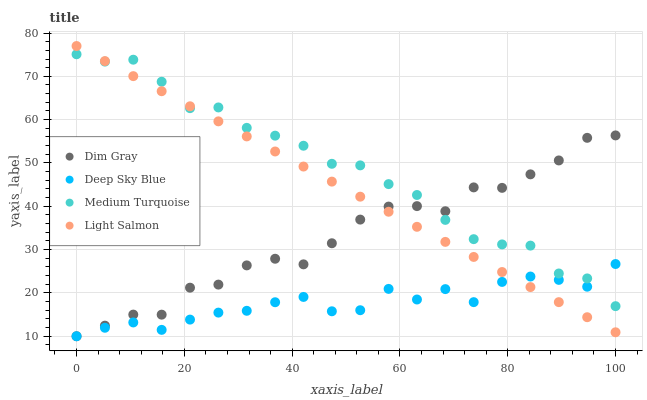Does Deep Sky Blue have the minimum area under the curve?
Answer yes or no. Yes. Does Medium Turquoise have the maximum area under the curve?
Answer yes or no. Yes. Does Dim Gray have the minimum area under the curve?
Answer yes or no. No. Does Dim Gray have the maximum area under the curve?
Answer yes or no. No. Is Light Salmon the smoothest?
Answer yes or no. Yes. Is Deep Sky Blue the roughest?
Answer yes or no. Yes. Is Dim Gray the smoothest?
Answer yes or no. No. Is Dim Gray the roughest?
Answer yes or no. No. Does Dim Gray have the lowest value?
Answer yes or no. Yes. Does Medium Turquoise have the lowest value?
Answer yes or no. No. Does Light Salmon have the highest value?
Answer yes or no. Yes. Does Dim Gray have the highest value?
Answer yes or no. No. Does Medium Turquoise intersect Light Salmon?
Answer yes or no. Yes. Is Medium Turquoise less than Light Salmon?
Answer yes or no. No. Is Medium Turquoise greater than Light Salmon?
Answer yes or no. No. 